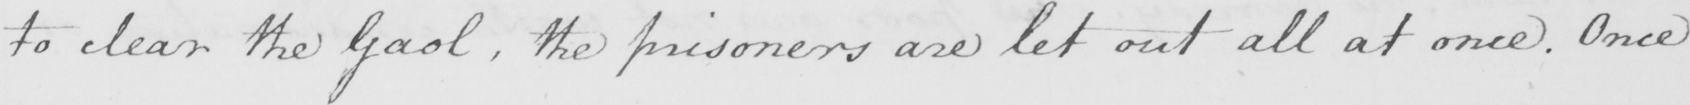Can you read and transcribe this handwriting? to clear the Gaol , the prisoners are let out all at once . Once 